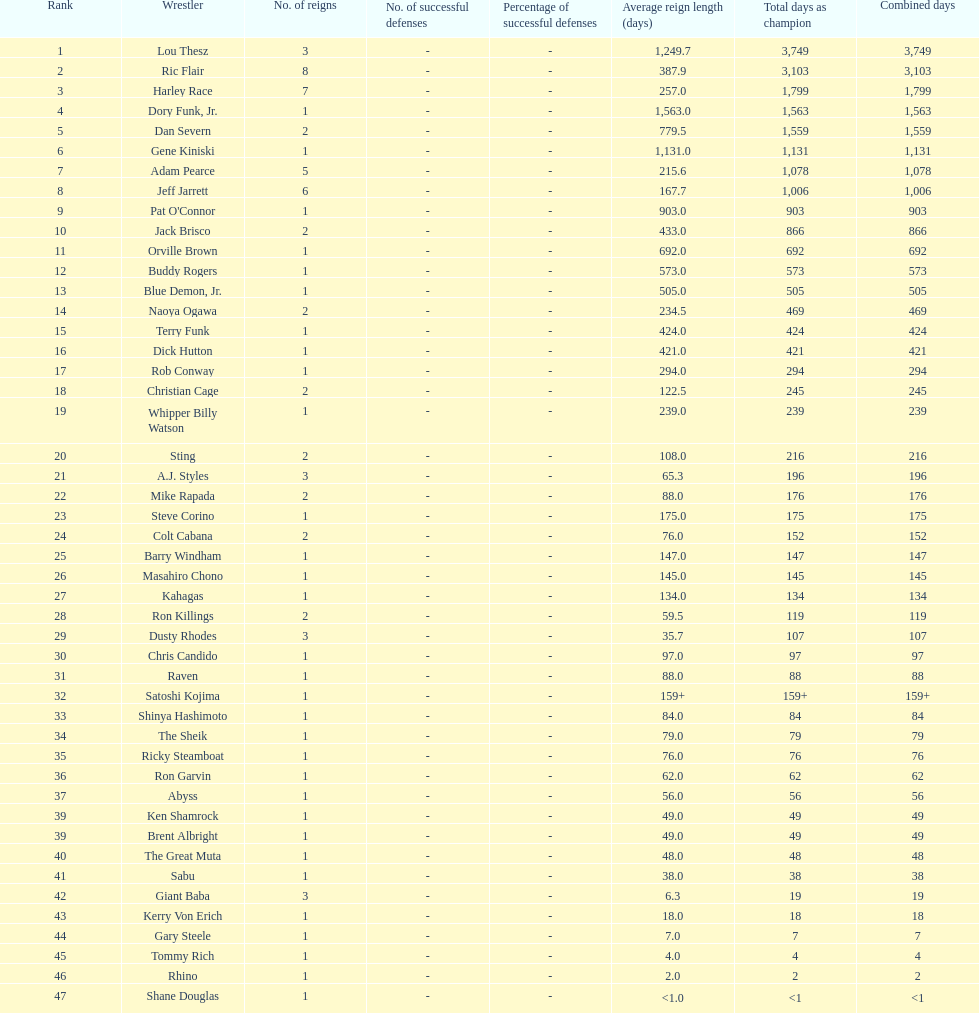How long did orville brown remain nwa world heavyweight champion? 692 days. 